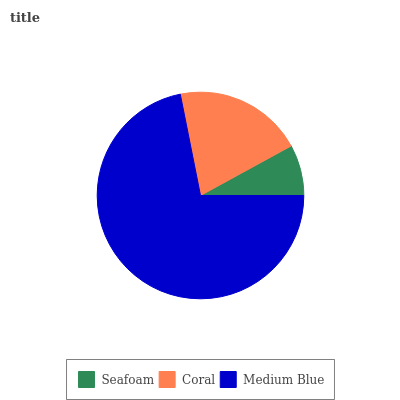Is Seafoam the minimum?
Answer yes or no. Yes. Is Medium Blue the maximum?
Answer yes or no. Yes. Is Coral the minimum?
Answer yes or no. No. Is Coral the maximum?
Answer yes or no. No. Is Coral greater than Seafoam?
Answer yes or no. Yes. Is Seafoam less than Coral?
Answer yes or no. Yes. Is Seafoam greater than Coral?
Answer yes or no. No. Is Coral less than Seafoam?
Answer yes or no. No. Is Coral the high median?
Answer yes or no. Yes. Is Coral the low median?
Answer yes or no. Yes. Is Medium Blue the high median?
Answer yes or no. No. Is Medium Blue the low median?
Answer yes or no. No. 